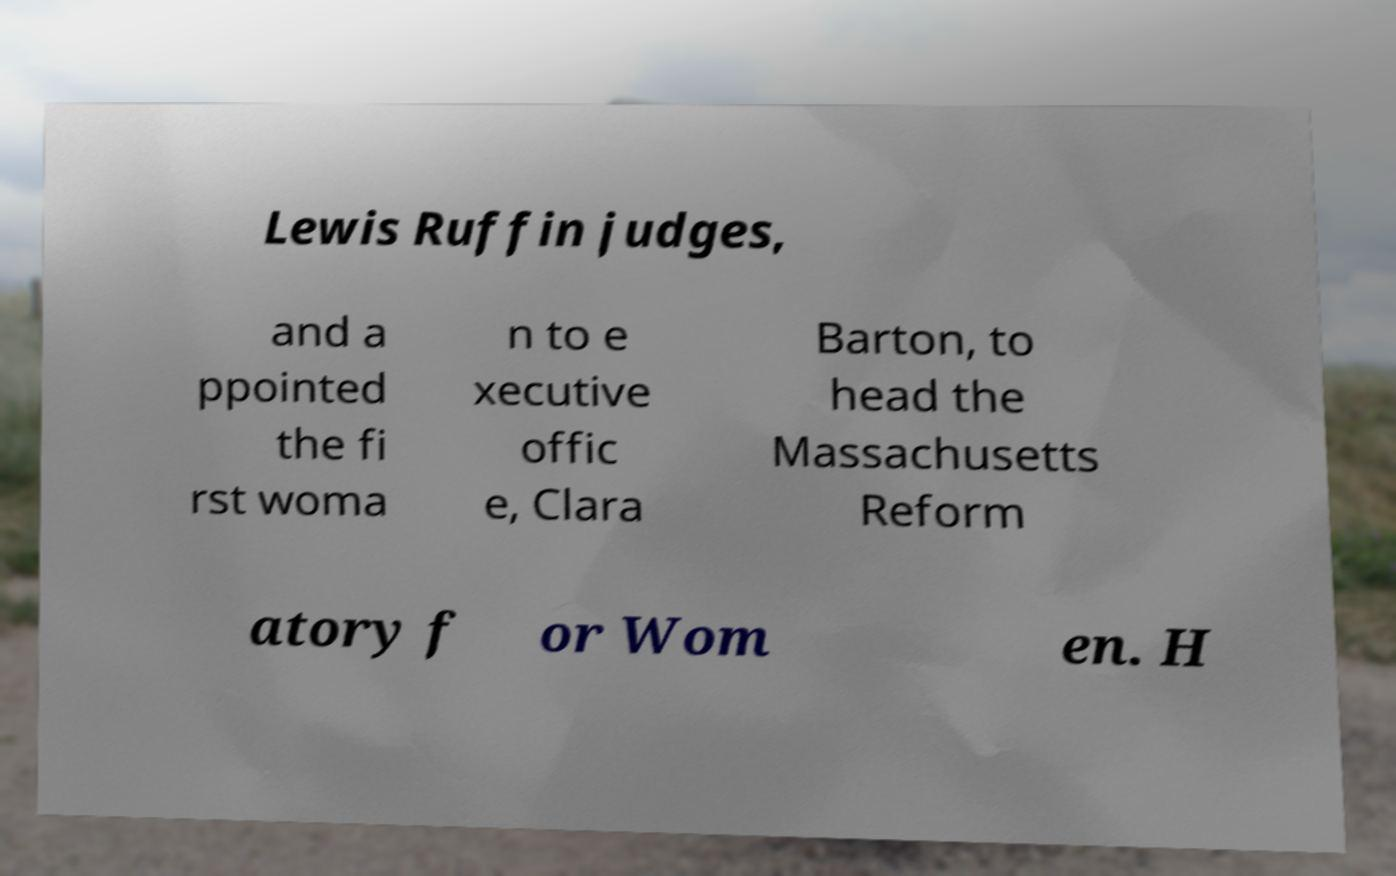Could you assist in decoding the text presented in this image and type it out clearly? Lewis Ruffin judges, and a ppointed the fi rst woma n to e xecutive offic e, Clara Barton, to head the Massachusetts Reform atory f or Wom en. H 